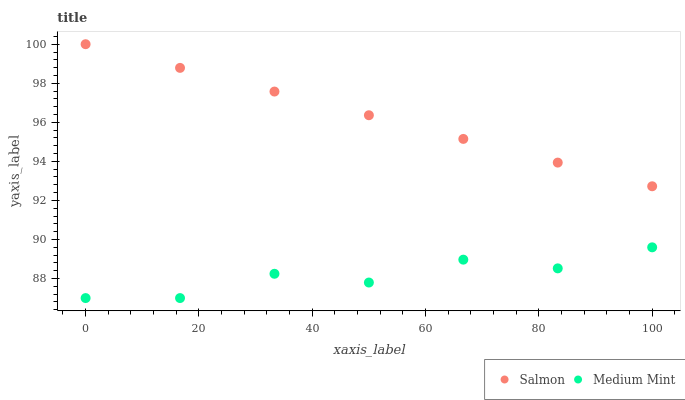Does Medium Mint have the minimum area under the curve?
Answer yes or no. Yes. Does Salmon have the maximum area under the curve?
Answer yes or no. Yes. Does Salmon have the minimum area under the curve?
Answer yes or no. No. Is Salmon the smoothest?
Answer yes or no. Yes. Is Medium Mint the roughest?
Answer yes or no. Yes. Is Salmon the roughest?
Answer yes or no. No. Does Medium Mint have the lowest value?
Answer yes or no. Yes. Does Salmon have the lowest value?
Answer yes or no. No. Does Salmon have the highest value?
Answer yes or no. Yes. Is Medium Mint less than Salmon?
Answer yes or no. Yes. Is Salmon greater than Medium Mint?
Answer yes or no. Yes. Does Medium Mint intersect Salmon?
Answer yes or no. No. 